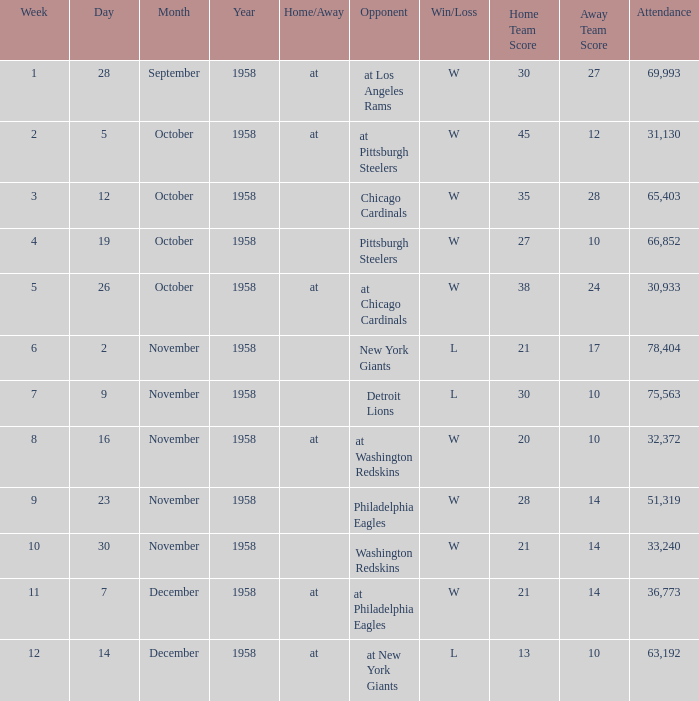Which day witnessed more than 51,319 attendees during week 4? October 19, 1958. Could you help me parse every detail presented in this table? {'header': ['Week', 'Day', 'Month', 'Year', 'Home/Away', 'Opponent', 'Win/Loss', 'Home Team Score', 'Away Team Score', 'Attendance'], 'rows': [['1', '28', 'September', '1958', 'at', 'at Los Angeles Rams', 'W', '30', '27', '69,993'], ['2', '5', 'October', '1958', 'at', 'at Pittsburgh Steelers', 'W', '45', '12', '31,130'], ['3', '12', 'October', '1958', '', 'Chicago Cardinals', 'W', '35', '28', '65,403'], ['4', '19', 'October', '1958', '', 'Pittsburgh Steelers', 'W', '27', '10', '66,852'], ['5', '26', 'October', '1958', 'at', 'at Chicago Cardinals', 'W', '38', '24', '30,933'], ['6', '2', 'November', '1958', '', 'New York Giants', 'L', '21', '17', '78,404'], ['7', '9', 'November', '1958', '', 'Detroit Lions', 'L', '30', '10', '75,563'], ['8', '16', 'November', '1958', 'at', 'at Washington Redskins', 'W', '20', '10', '32,372'], ['9', '23', 'November', '1958', '', 'Philadelphia Eagles', 'W', '28', '14', '51,319'], ['10', '30', 'November', '1958', '', 'Washington Redskins', 'W', '21', '14', '33,240'], ['11', '7', 'December', '1958', 'at', 'at Philadelphia Eagles', 'W', '21', '14', '36,773'], ['12', '14', 'December', '1958', 'at', 'at New York Giants', 'L', '13', '10', '63,192']]} 